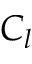Convert formula to latex. <formula><loc_0><loc_0><loc_500><loc_500>C _ { l }</formula> 